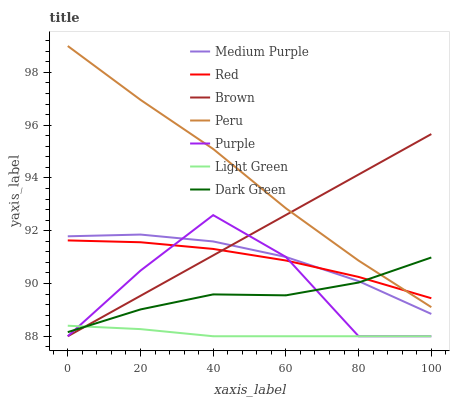Does Light Green have the minimum area under the curve?
Answer yes or no. Yes. Does Peru have the maximum area under the curve?
Answer yes or no. Yes. Does Purple have the minimum area under the curve?
Answer yes or no. No. Does Purple have the maximum area under the curve?
Answer yes or no. No. Is Brown the smoothest?
Answer yes or no. Yes. Is Purple the roughest?
Answer yes or no. Yes. Is Peru the smoothest?
Answer yes or no. No. Is Peru the roughest?
Answer yes or no. No. Does Brown have the lowest value?
Answer yes or no. Yes. Does Peru have the lowest value?
Answer yes or no. No. Does Peru have the highest value?
Answer yes or no. Yes. Does Purple have the highest value?
Answer yes or no. No. Is Light Green less than Peru?
Answer yes or no. Yes. Is Red greater than Light Green?
Answer yes or no. Yes. Does Brown intersect Medium Purple?
Answer yes or no. Yes. Is Brown less than Medium Purple?
Answer yes or no. No. Is Brown greater than Medium Purple?
Answer yes or no. No. Does Light Green intersect Peru?
Answer yes or no. No. 